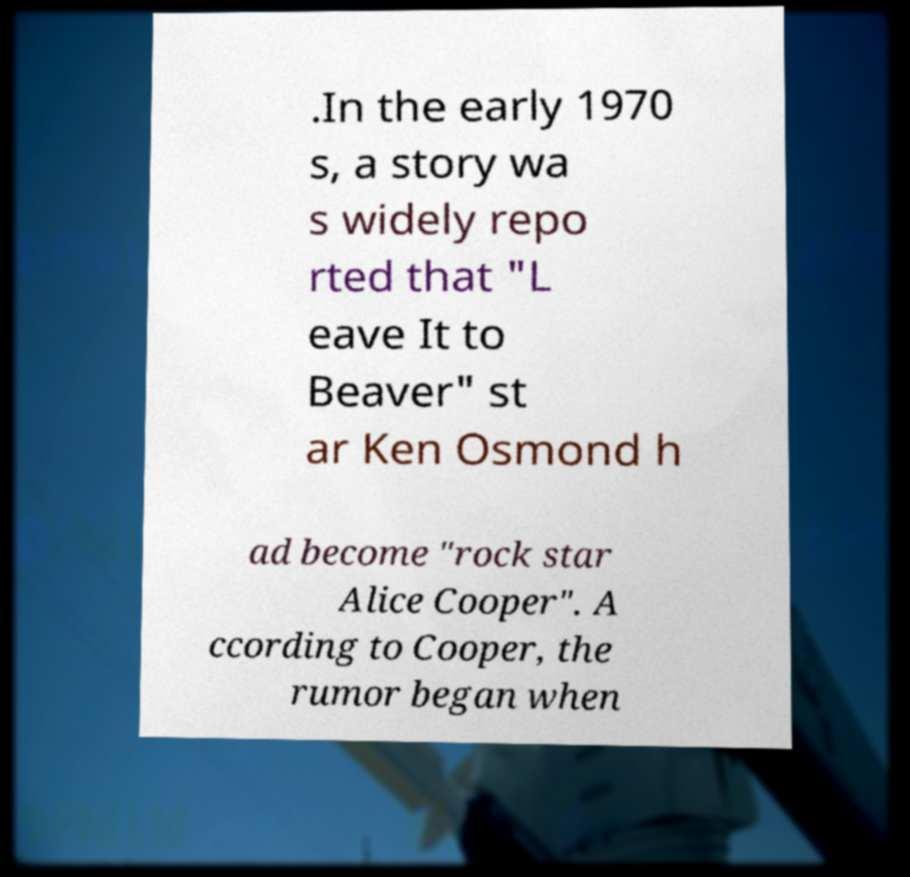For documentation purposes, I need the text within this image transcribed. Could you provide that? .In the early 1970 s, a story wa s widely repo rted that "L eave It to Beaver" st ar Ken Osmond h ad become "rock star Alice Cooper". A ccording to Cooper, the rumor began when 